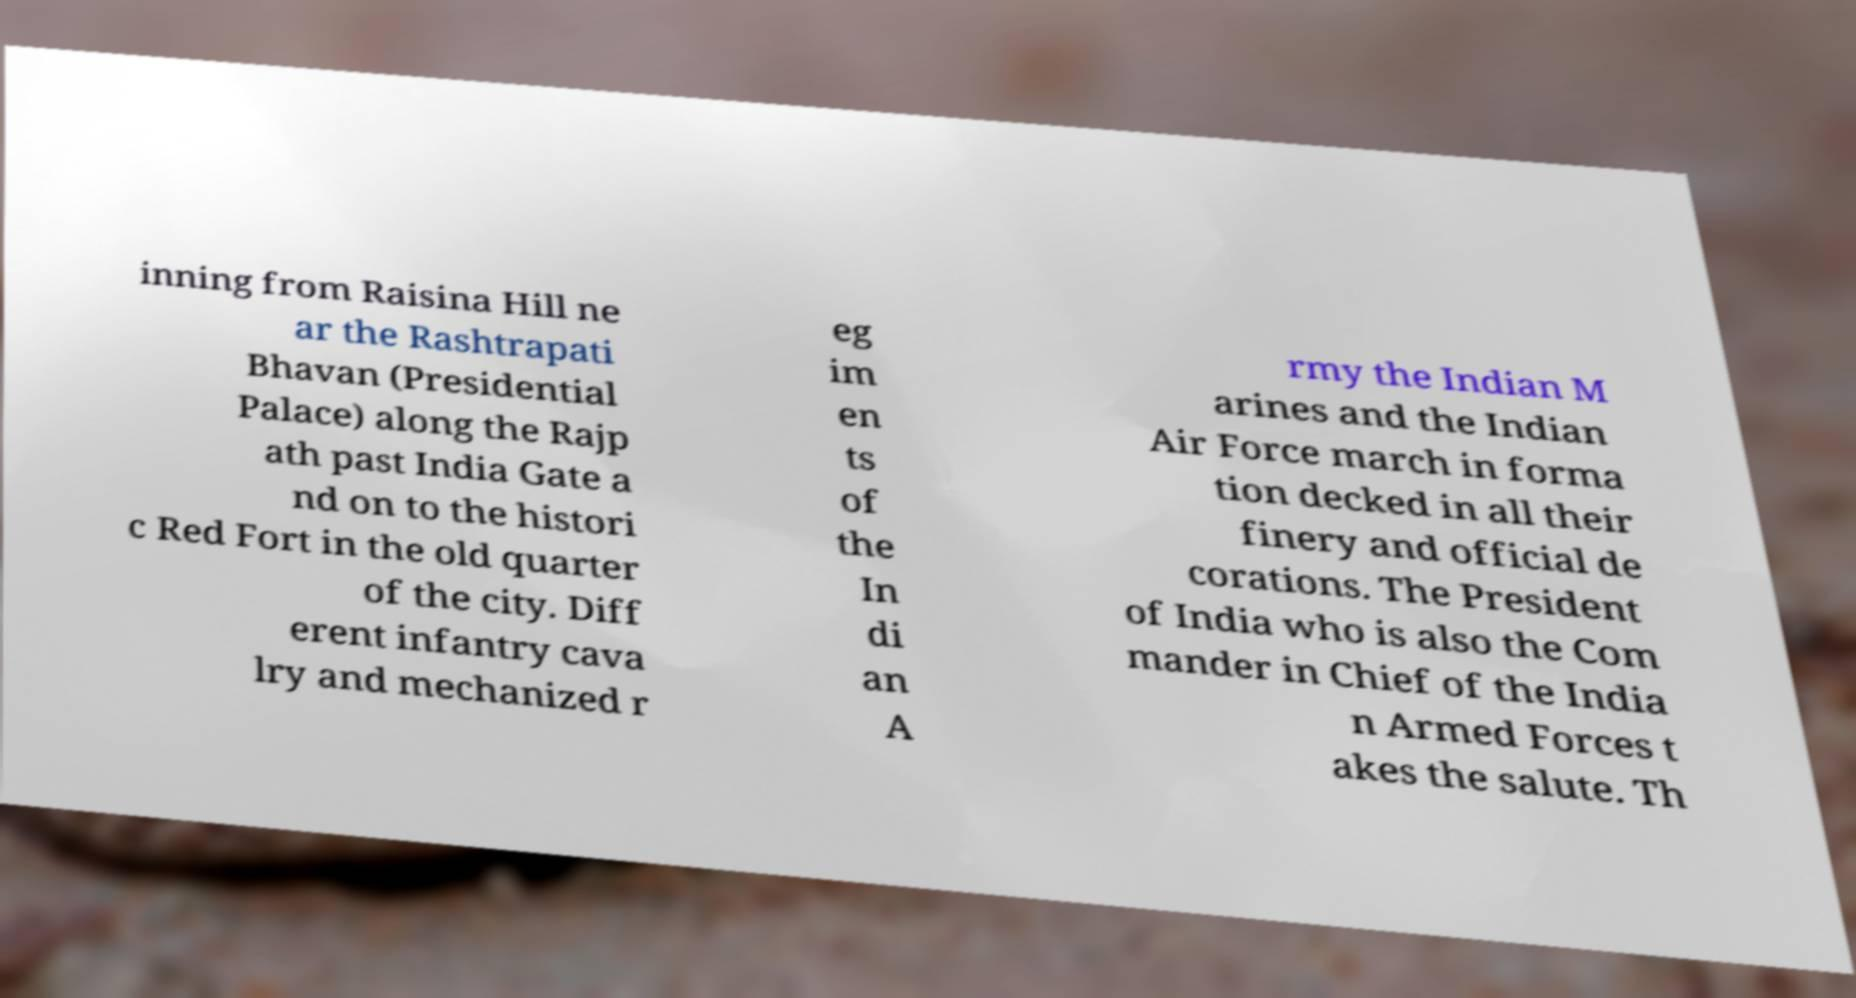Can you read and provide the text displayed in the image?This photo seems to have some interesting text. Can you extract and type it out for me? inning from Raisina Hill ne ar the Rashtrapati Bhavan (Presidential Palace) along the Rajp ath past India Gate a nd on to the histori c Red Fort in the old quarter of the city. Diff erent infantry cava lry and mechanized r eg im en ts of the In di an A rmy the Indian M arines and the Indian Air Force march in forma tion decked in all their finery and official de corations. The President of India who is also the Com mander in Chief of the India n Armed Forces t akes the salute. Th 